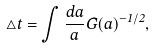Convert formula to latex. <formula><loc_0><loc_0><loc_500><loc_500>\triangle t = \int \frac { d a } { a } G ( a ) ^ { - 1 / 2 } ,</formula> 